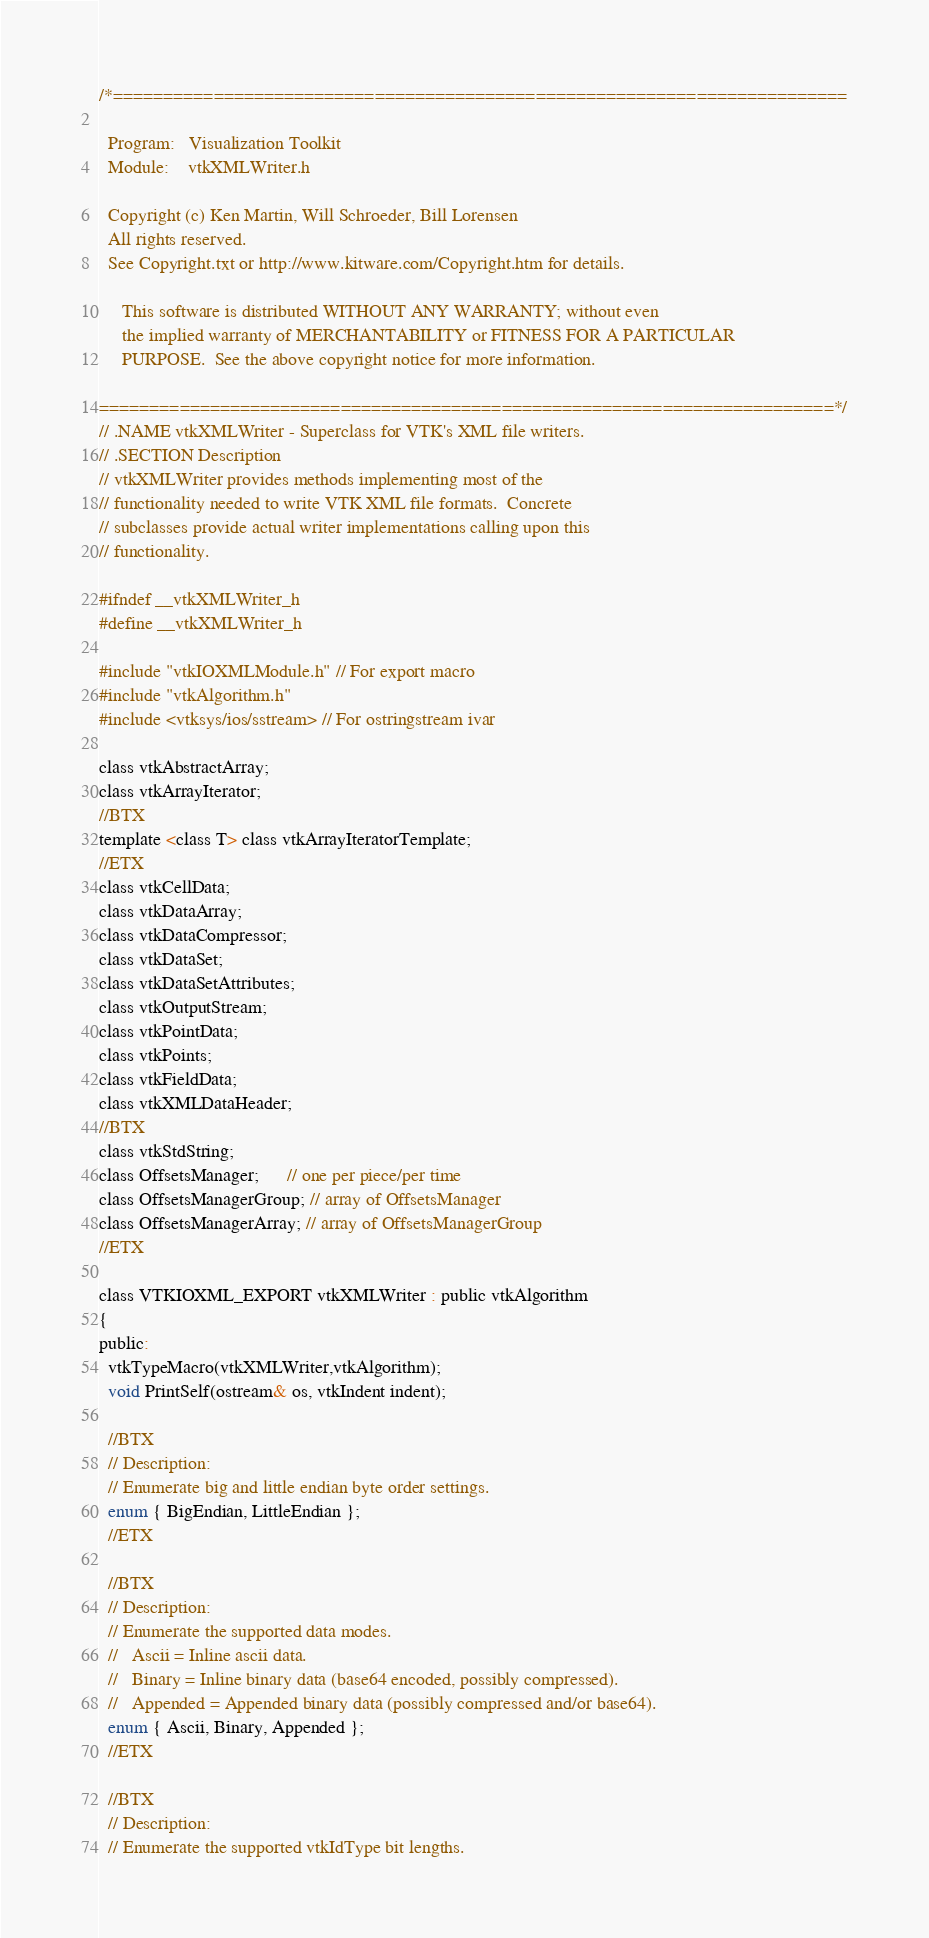<code> <loc_0><loc_0><loc_500><loc_500><_C_>/*=========================================================================

  Program:   Visualization Toolkit
  Module:    vtkXMLWriter.h

  Copyright (c) Ken Martin, Will Schroeder, Bill Lorensen
  All rights reserved.
  See Copyright.txt or http://www.kitware.com/Copyright.htm for details.

     This software is distributed WITHOUT ANY WARRANTY; without even
     the implied warranty of MERCHANTABILITY or FITNESS FOR A PARTICULAR
     PURPOSE.  See the above copyright notice for more information.

=========================================================================*/
// .NAME vtkXMLWriter - Superclass for VTK's XML file writers.
// .SECTION Description
// vtkXMLWriter provides methods implementing most of the
// functionality needed to write VTK XML file formats.  Concrete
// subclasses provide actual writer implementations calling upon this
// functionality.

#ifndef __vtkXMLWriter_h
#define __vtkXMLWriter_h

#include "vtkIOXMLModule.h" // For export macro
#include "vtkAlgorithm.h"
#include <vtksys/ios/sstream> // For ostringstream ivar

class vtkAbstractArray;
class vtkArrayIterator;
//BTX
template <class T> class vtkArrayIteratorTemplate;
//ETX
class vtkCellData;
class vtkDataArray;
class vtkDataCompressor;
class vtkDataSet;
class vtkDataSetAttributes;
class vtkOutputStream;
class vtkPointData;
class vtkPoints;
class vtkFieldData;
class vtkXMLDataHeader;
//BTX
class vtkStdString;
class OffsetsManager;      // one per piece/per time
class OffsetsManagerGroup; // array of OffsetsManager
class OffsetsManagerArray; // array of OffsetsManagerGroup
//ETX

class VTKIOXML_EXPORT vtkXMLWriter : public vtkAlgorithm
{
public:
  vtkTypeMacro(vtkXMLWriter,vtkAlgorithm);
  void PrintSelf(ostream& os, vtkIndent indent);

  //BTX
  // Description:
  // Enumerate big and little endian byte order settings.
  enum { BigEndian, LittleEndian };
  //ETX

  //BTX
  // Description:
  // Enumerate the supported data modes.
  //   Ascii = Inline ascii data.
  //   Binary = Inline binary data (base64 encoded, possibly compressed).
  //   Appended = Appended binary data (possibly compressed and/or base64).
  enum { Ascii, Binary, Appended };
  //ETX

  //BTX
  // Description:
  // Enumerate the supported vtkIdType bit lengths.</code> 